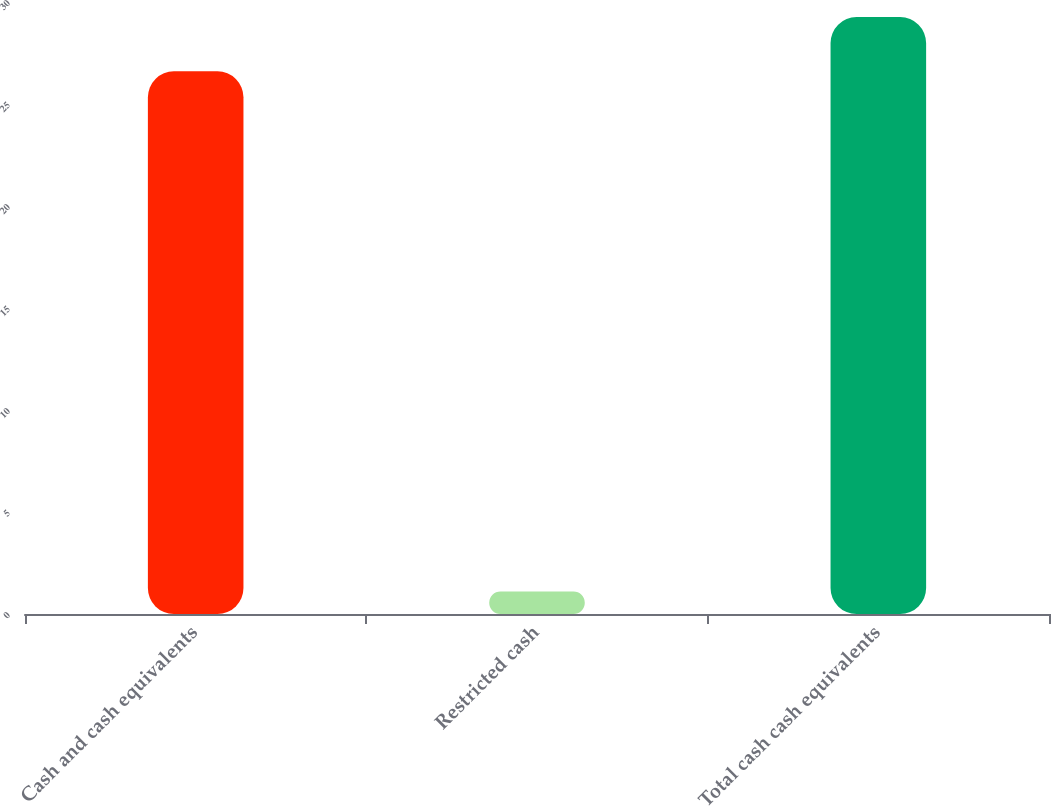Convert chart to OTSL. <chart><loc_0><loc_0><loc_500><loc_500><bar_chart><fcel>Cash and cash equivalents<fcel>Restricted cash<fcel>Total cash cash equivalents<nl><fcel>26.6<fcel>1.1<fcel>29.26<nl></chart> 